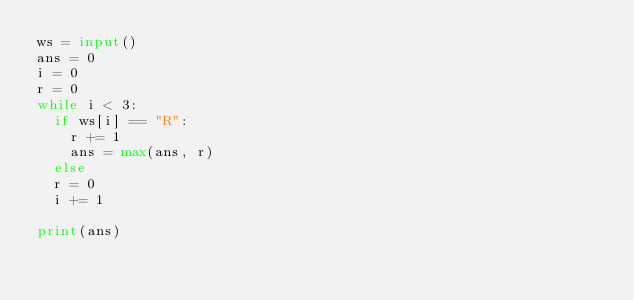Convert code to text. <code><loc_0><loc_0><loc_500><loc_500><_Python_>ws = input()
ans = 0
i = 0
r = 0
while i < 3:
  if ws[i] == "R":
  	r += 1
    ans = max(ans, r)
  else
	r = 0
  i += 1

print(ans)

</code> 